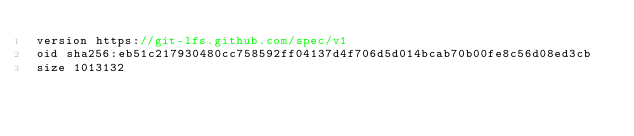<code> <loc_0><loc_0><loc_500><loc_500><_TypeScript_>version https://git-lfs.github.com/spec/v1
oid sha256:eb51c217930480cc758592ff04137d4f706d5d014bcab70b00fe8c56d08ed3cb
size 1013132
</code> 